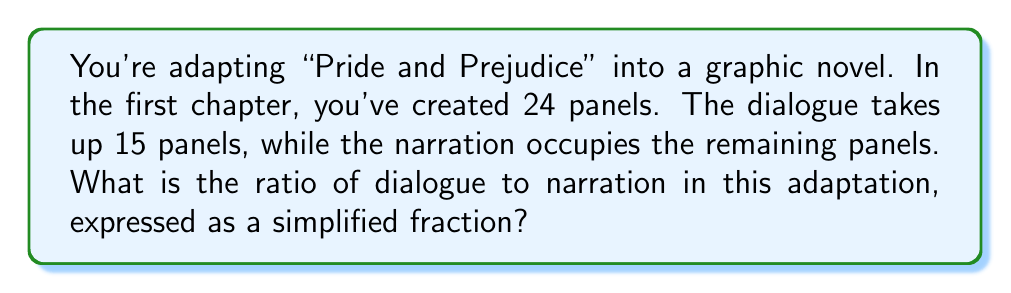Give your solution to this math problem. To solve this problem, we need to follow these steps:

1. Identify the number of panels for dialogue and narration:
   - Dialogue panels: 15
   - Narration panels: 24 - 15 = 9

2. Set up the ratio of dialogue to narration:
   $$\frac{\text{Dialogue panels}}{\text{Narration panels}} = \frac{15}{9}$$

3. Simplify the fraction by finding the greatest common divisor (GCD):
   The GCD of 15 and 9 is 3.

4. Divide both the numerator and denominator by the GCD:
   $$\frac{15 \div 3}{9 \div 3} = \frac{5}{3}$$

Therefore, the simplified ratio of dialogue to narration is 5:3.
Answer: $\frac{5}{3}$ or 5:3 